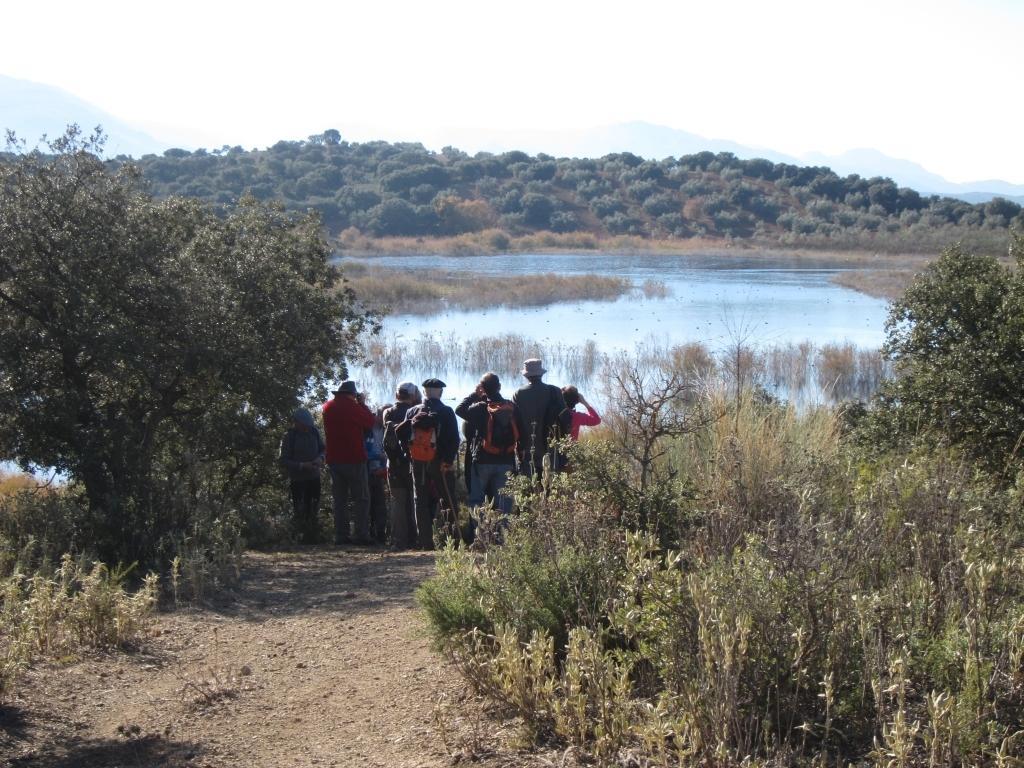Could you give a brief overview of what you see in this image? In this image we can see a group of people standing on the side of a lake. Here we can see the trees on the left side and the right side as well. In the background, we can see the mountains and trees. 